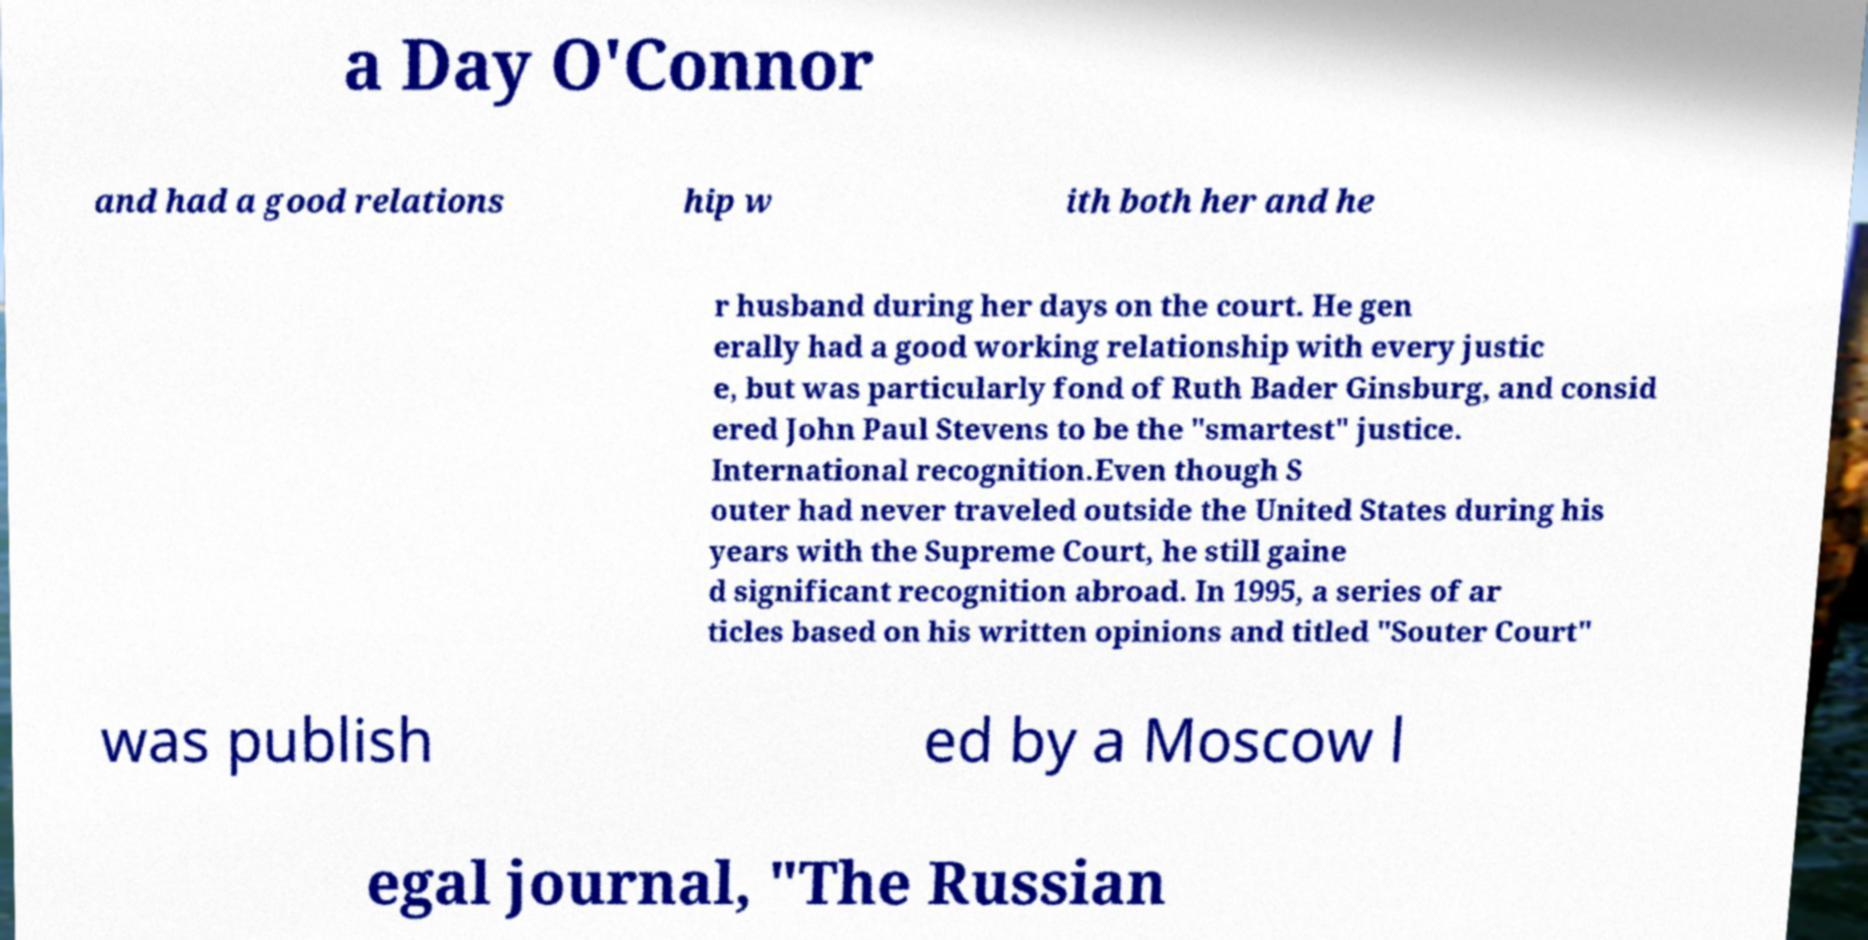Can you accurately transcribe the text from the provided image for me? a Day O'Connor and had a good relations hip w ith both her and he r husband during her days on the court. He gen erally had a good working relationship with every justic e, but was particularly fond of Ruth Bader Ginsburg, and consid ered John Paul Stevens to be the "smartest" justice. International recognition.Even though S outer had never traveled outside the United States during his years with the Supreme Court, he still gaine d significant recognition abroad. In 1995, a series of ar ticles based on his written opinions and titled "Souter Court" was publish ed by a Moscow l egal journal, "The Russian 